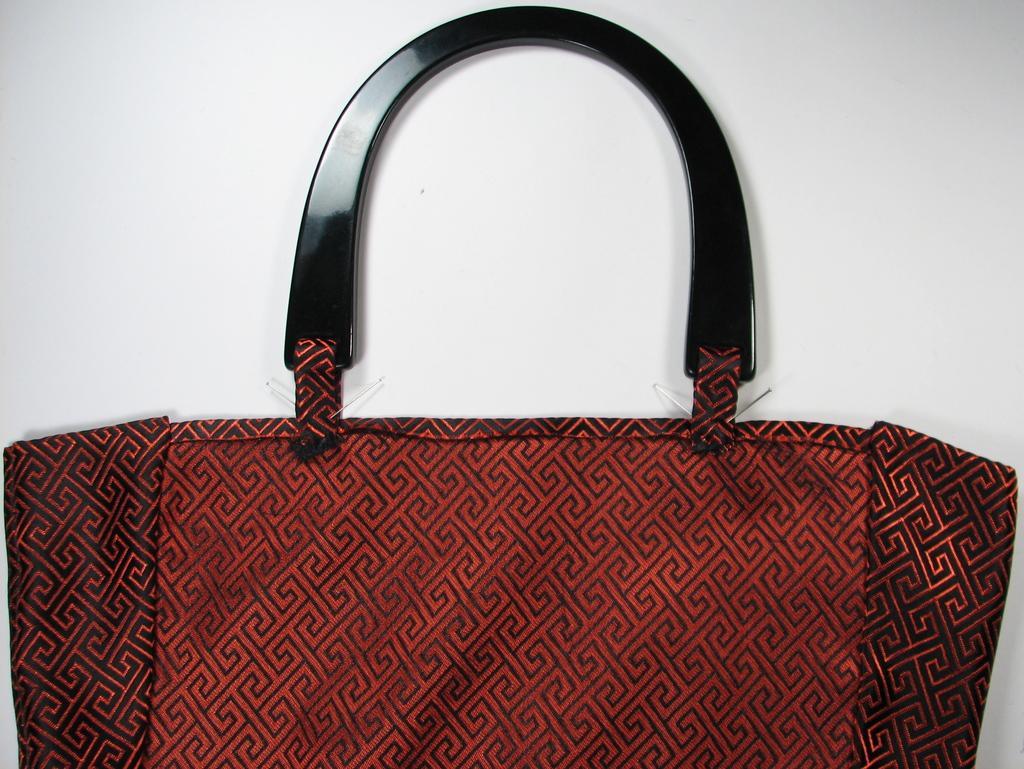How would you summarize this image in a sentence or two? In the picture we can see a hand bag which is red in color with lines and handle is black in color. 